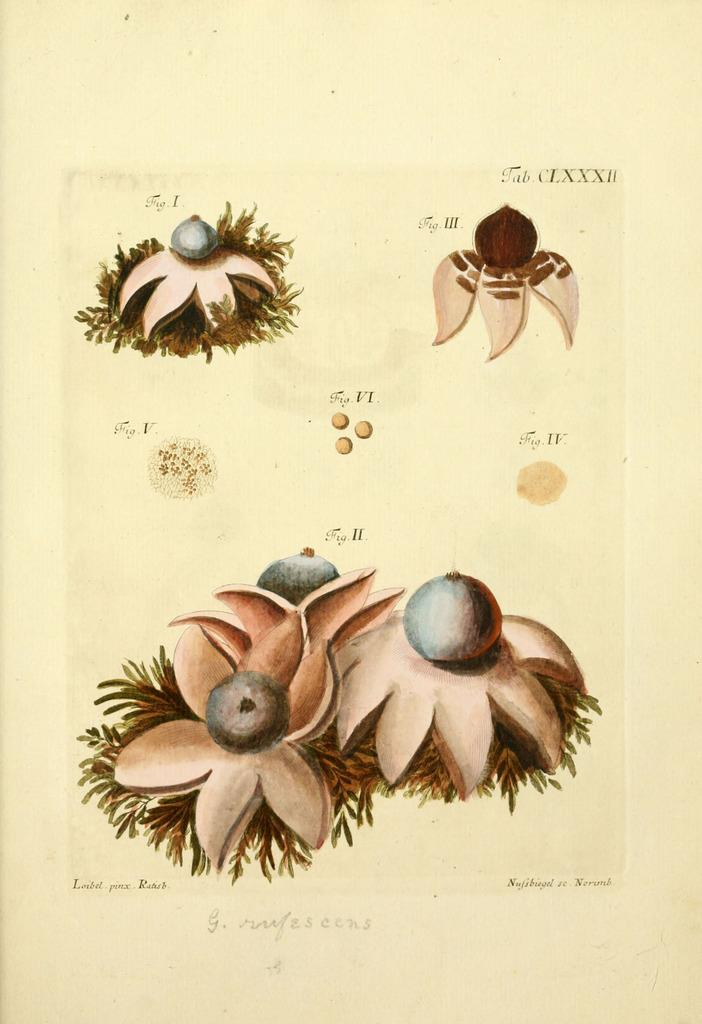What color is the paper that is visible in the image? The paper in the image is yellow. What is depicted on the yellow paper? The yellow paper has drawings of flowers on it. What type of vest is being worn by the flowers on the yellow paper? There are no people or clothing items, including vests, depicted on the yellow paper. The image only shows drawings of flowers on the paper. 